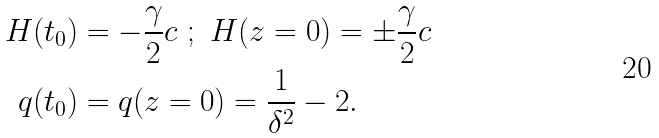<formula> <loc_0><loc_0><loc_500><loc_500>H ( t _ { 0 } ) & = - \frac { \gamma } { 2 } c \ ; \ H ( z = 0 ) = \pm \frac { \gamma } { 2 } c \\ q ( t _ { 0 } ) & = q ( z = 0 ) = \frac { 1 } { \delta ^ { 2 } } - 2 .</formula> 